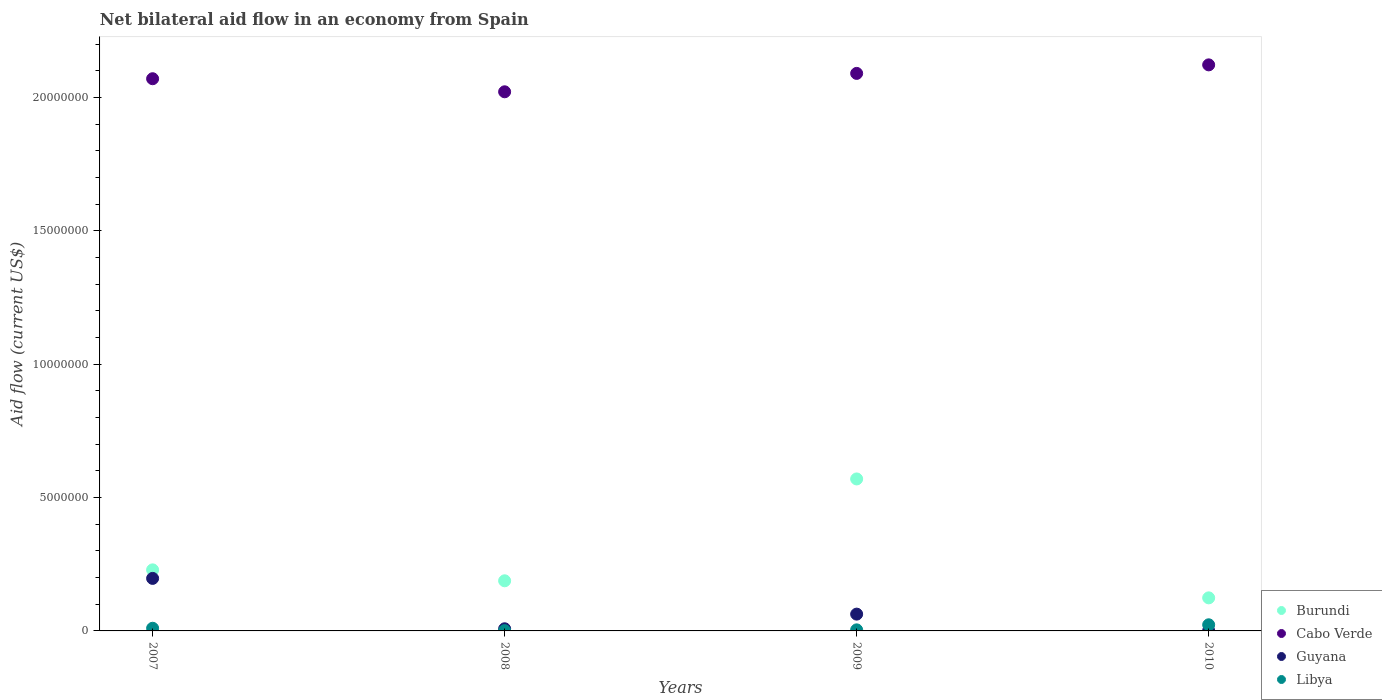What is the net bilateral aid flow in Burundi in 2009?
Ensure brevity in your answer.  5.70e+06. Across all years, what is the maximum net bilateral aid flow in Guyana?
Your answer should be compact. 1.97e+06. Across all years, what is the minimum net bilateral aid flow in Burundi?
Make the answer very short. 1.24e+06. In which year was the net bilateral aid flow in Libya minimum?
Keep it short and to the point. 2008. What is the total net bilateral aid flow in Burundi in the graph?
Provide a short and direct response. 1.11e+07. What is the difference between the net bilateral aid flow in Cabo Verde in 2007 and that in 2010?
Ensure brevity in your answer.  -5.20e+05. What is the difference between the net bilateral aid flow in Burundi in 2010 and the net bilateral aid flow in Libya in 2008?
Make the answer very short. 1.23e+06. What is the average net bilateral aid flow in Burundi per year?
Your answer should be compact. 2.78e+06. In the year 2007, what is the difference between the net bilateral aid flow in Guyana and net bilateral aid flow in Libya?
Give a very brief answer. 1.87e+06. Is the net bilateral aid flow in Libya in 2008 less than that in 2009?
Your response must be concise. Yes. What is the difference between the highest and the lowest net bilateral aid flow in Burundi?
Keep it short and to the point. 4.46e+06. Is the sum of the net bilateral aid flow in Libya in 2008 and 2010 greater than the maximum net bilateral aid flow in Cabo Verde across all years?
Offer a terse response. No. Is it the case that in every year, the sum of the net bilateral aid flow in Burundi and net bilateral aid flow in Guyana  is greater than the sum of net bilateral aid flow in Cabo Verde and net bilateral aid flow in Libya?
Keep it short and to the point. Yes. Is it the case that in every year, the sum of the net bilateral aid flow in Libya and net bilateral aid flow in Burundi  is greater than the net bilateral aid flow in Cabo Verde?
Give a very brief answer. No. Does the net bilateral aid flow in Guyana monotonically increase over the years?
Give a very brief answer. No. Are the values on the major ticks of Y-axis written in scientific E-notation?
Offer a very short reply. No. Does the graph contain grids?
Your response must be concise. No. Where does the legend appear in the graph?
Provide a short and direct response. Bottom right. How many legend labels are there?
Your answer should be very brief. 4. How are the legend labels stacked?
Your response must be concise. Vertical. What is the title of the graph?
Offer a terse response. Net bilateral aid flow in an economy from Spain. Does "Czech Republic" appear as one of the legend labels in the graph?
Ensure brevity in your answer.  No. What is the label or title of the Y-axis?
Your answer should be compact. Aid flow (current US$). What is the Aid flow (current US$) of Burundi in 2007?
Ensure brevity in your answer.  2.29e+06. What is the Aid flow (current US$) of Cabo Verde in 2007?
Offer a terse response. 2.07e+07. What is the Aid flow (current US$) in Guyana in 2007?
Your answer should be compact. 1.97e+06. What is the Aid flow (current US$) of Burundi in 2008?
Make the answer very short. 1.88e+06. What is the Aid flow (current US$) in Cabo Verde in 2008?
Make the answer very short. 2.02e+07. What is the Aid flow (current US$) of Guyana in 2008?
Give a very brief answer. 8.00e+04. What is the Aid flow (current US$) of Libya in 2008?
Provide a short and direct response. 10000. What is the Aid flow (current US$) in Burundi in 2009?
Your answer should be very brief. 5.70e+06. What is the Aid flow (current US$) of Cabo Verde in 2009?
Your answer should be very brief. 2.09e+07. What is the Aid flow (current US$) in Guyana in 2009?
Your answer should be compact. 6.30e+05. What is the Aid flow (current US$) of Libya in 2009?
Offer a very short reply. 4.00e+04. What is the Aid flow (current US$) in Burundi in 2010?
Your response must be concise. 1.24e+06. What is the Aid flow (current US$) of Cabo Verde in 2010?
Your answer should be very brief. 2.12e+07. What is the Aid flow (current US$) of Guyana in 2010?
Provide a short and direct response. 10000. Across all years, what is the maximum Aid flow (current US$) in Burundi?
Give a very brief answer. 5.70e+06. Across all years, what is the maximum Aid flow (current US$) in Cabo Verde?
Make the answer very short. 2.12e+07. Across all years, what is the maximum Aid flow (current US$) of Guyana?
Keep it short and to the point. 1.97e+06. Across all years, what is the minimum Aid flow (current US$) in Burundi?
Your answer should be compact. 1.24e+06. Across all years, what is the minimum Aid flow (current US$) in Cabo Verde?
Your response must be concise. 2.02e+07. What is the total Aid flow (current US$) in Burundi in the graph?
Make the answer very short. 1.11e+07. What is the total Aid flow (current US$) of Cabo Verde in the graph?
Make the answer very short. 8.31e+07. What is the total Aid flow (current US$) of Guyana in the graph?
Make the answer very short. 2.69e+06. What is the difference between the Aid flow (current US$) of Burundi in 2007 and that in 2008?
Keep it short and to the point. 4.10e+05. What is the difference between the Aid flow (current US$) in Guyana in 2007 and that in 2008?
Give a very brief answer. 1.89e+06. What is the difference between the Aid flow (current US$) of Libya in 2007 and that in 2008?
Make the answer very short. 9.00e+04. What is the difference between the Aid flow (current US$) of Burundi in 2007 and that in 2009?
Offer a very short reply. -3.41e+06. What is the difference between the Aid flow (current US$) of Guyana in 2007 and that in 2009?
Ensure brevity in your answer.  1.34e+06. What is the difference between the Aid flow (current US$) of Burundi in 2007 and that in 2010?
Your answer should be very brief. 1.05e+06. What is the difference between the Aid flow (current US$) in Cabo Verde in 2007 and that in 2010?
Provide a succinct answer. -5.20e+05. What is the difference between the Aid flow (current US$) of Guyana in 2007 and that in 2010?
Ensure brevity in your answer.  1.96e+06. What is the difference between the Aid flow (current US$) in Burundi in 2008 and that in 2009?
Provide a succinct answer. -3.82e+06. What is the difference between the Aid flow (current US$) in Cabo Verde in 2008 and that in 2009?
Your answer should be compact. -6.90e+05. What is the difference between the Aid flow (current US$) of Guyana in 2008 and that in 2009?
Your response must be concise. -5.50e+05. What is the difference between the Aid flow (current US$) of Libya in 2008 and that in 2009?
Give a very brief answer. -3.00e+04. What is the difference between the Aid flow (current US$) in Burundi in 2008 and that in 2010?
Provide a succinct answer. 6.40e+05. What is the difference between the Aid flow (current US$) of Cabo Verde in 2008 and that in 2010?
Your response must be concise. -1.01e+06. What is the difference between the Aid flow (current US$) in Libya in 2008 and that in 2010?
Your response must be concise. -2.20e+05. What is the difference between the Aid flow (current US$) in Burundi in 2009 and that in 2010?
Keep it short and to the point. 4.46e+06. What is the difference between the Aid flow (current US$) in Cabo Verde in 2009 and that in 2010?
Make the answer very short. -3.20e+05. What is the difference between the Aid flow (current US$) of Guyana in 2009 and that in 2010?
Your response must be concise. 6.20e+05. What is the difference between the Aid flow (current US$) of Libya in 2009 and that in 2010?
Provide a succinct answer. -1.90e+05. What is the difference between the Aid flow (current US$) in Burundi in 2007 and the Aid flow (current US$) in Cabo Verde in 2008?
Give a very brief answer. -1.79e+07. What is the difference between the Aid flow (current US$) of Burundi in 2007 and the Aid flow (current US$) of Guyana in 2008?
Your answer should be very brief. 2.21e+06. What is the difference between the Aid flow (current US$) of Burundi in 2007 and the Aid flow (current US$) of Libya in 2008?
Keep it short and to the point. 2.28e+06. What is the difference between the Aid flow (current US$) of Cabo Verde in 2007 and the Aid flow (current US$) of Guyana in 2008?
Offer a very short reply. 2.06e+07. What is the difference between the Aid flow (current US$) in Cabo Verde in 2007 and the Aid flow (current US$) in Libya in 2008?
Provide a short and direct response. 2.07e+07. What is the difference between the Aid flow (current US$) in Guyana in 2007 and the Aid flow (current US$) in Libya in 2008?
Your answer should be very brief. 1.96e+06. What is the difference between the Aid flow (current US$) in Burundi in 2007 and the Aid flow (current US$) in Cabo Verde in 2009?
Your response must be concise. -1.86e+07. What is the difference between the Aid flow (current US$) in Burundi in 2007 and the Aid flow (current US$) in Guyana in 2009?
Provide a short and direct response. 1.66e+06. What is the difference between the Aid flow (current US$) of Burundi in 2007 and the Aid flow (current US$) of Libya in 2009?
Your answer should be very brief. 2.25e+06. What is the difference between the Aid flow (current US$) of Cabo Verde in 2007 and the Aid flow (current US$) of Guyana in 2009?
Offer a terse response. 2.01e+07. What is the difference between the Aid flow (current US$) in Cabo Verde in 2007 and the Aid flow (current US$) in Libya in 2009?
Ensure brevity in your answer.  2.07e+07. What is the difference between the Aid flow (current US$) in Guyana in 2007 and the Aid flow (current US$) in Libya in 2009?
Your response must be concise. 1.93e+06. What is the difference between the Aid flow (current US$) in Burundi in 2007 and the Aid flow (current US$) in Cabo Verde in 2010?
Provide a succinct answer. -1.89e+07. What is the difference between the Aid flow (current US$) of Burundi in 2007 and the Aid flow (current US$) of Guyana in 2010?
Offer a terse response. 2.28e+06. What is the difference between the Aid flow (current US$) of Burundi in 2007 and the Aid flow (current US$) of Libya in 2010?
Provide a short and direct response. 2.06e+06. What is the difference between the Aid flow (current US$) in Cabo Verde in 2007 and the Aid flow (current US$) in Guyana in 2010?
Provide a short and direct response. 2.07e+07. What is the difference between the Aid flow (current US$) of Cabo Verde in 2007 and the Aid flow (current US$) of Libya in 2010?
Offer a terse response. 2.05e+07. What is the difference between the Aid flow (current US$) of Guyana in 2007 and the Aid flow (current US$) of Libya in 2010?
Your answer should be compact. 1.74e+06. What is the difference between the Aid flow (current US$) of Burundi in 2008 and the Aid flow (current US$) of Cabo Verde in 2009?
Keep it short and to the point. -1.90e+07. What is the difference between the Aid flow (current US$) of Burundi in 2008 and the Aid flow (current US$) of Guyana in 2009?
Provide a short and direct response. 1.25e+06. What is the difference between the Aid flow (current US$) in Burundi in 2008 and the Aid flow (current US$) in Libya in 2009?
Your answer should be very brief. 1.84e+06. What is the difference between the Aid flow (current US$) in Cabo Verde in 2008 and the Aid flow (current US$) in Guyana in 2009?
Your answer should be compact. 1.96e+07. What is the difference between the Aid flow (current US$) in Cabo Verde in 2008 and the Aid flow (current US$) in Libya in 2009?
Offer a very short reply. 2.02e+07. What is the difference between the Aid flow (current US$) of Burundi in 2008 and the Aid flow (current US$) of Cabo Verde in 2010?
Give a very brief answer. -1.94e+07. What is the difference between the Aid flow (current US$) in Burundi in 2008 and the Aid flow (current US$) in Guyana in 2010?
Provide a succinct answer. 1.87e+06. What is the difference between the Aid flow (current US$) of Burundi in 2008 and the Aid flow (current US$) of Libya in 2010?
Your response must be concise. 1.65e+06. What is the difference between the Aid flow (current US$) of Cabo Verde in 2008 and the Aid flow (current US$) of Guyana in 2010?
Provide a succinct answer. 2.02e+07. What is the difference between the Aid flow (current US$) of Cabo Verde in 2008 and the Aid flow (current US$) of Libya in 2010?
Your answer should be very brief. 2.00e+07. What is the difference between the Aid flow (current US$) in Burundi in 2009 and the Aid flow (current US$) in Cabo Verde in 2010?
Your response must be concise. -1.55e+07. What is the difference between the Aid flow (current US$) in Burundi in 2009 and the Aid flow (current US$) in Guyana in 2010?
Offer a terse response. 5.69e+06. What is the difference between the Aid flow (current US$) of Burundi in 2009 and the Aid flow (current US$) of Libya in 2010?
Provide a short and direct response. 5.47e+06. What is the difference between the Aid flow (current US$) in Cabo Verde in 2009 and the Aid flow (current US$) in Guyana in 2010?
Your answer should be compact. 2.09e+07. What is the difference between the Aid flow (current US$) in Cabo Verde in 2009 and the Aid flow (current US$) in Libya in 2010?
Your answer should be compact. 2.07e+07. What is the average Aid flow (current US$) of Burundi per year?
Your answer should be very brief. 2.78e+06. What is the average Aid flow (current US$) of Cabo Verde per year?
Offer a very short reply. 2.08e+07. What is the average Aid flow (current US$) in Guyana per year?
Your response must be concise. 6.72e+05. What is the average Aid flow (current US$) of Libya per year?
Make the answer very short. 9.50e+04. In the year 2007, what is the difference between the Aid flow (current US$) of Burundi and Aid flow (current US$) of Cabo Verde?
Your response must be concise. -1.84e+07. In the year 2007, what is the difference between the Aid flow (current US$) in Burundi and Aid flow (current US$) in Libya?
Provide a succinct answer. 2.19e+06. In the year 2007, what is the difference between the Aid flow (current US$) of Cabo Verde and Aid flow (current US$) of Guyana?
Offer a very short reply. 1.87e+07. In the year 2007, what is the difference between the Aid flow (current US$) in Cabo Verde and Aid flow (current US$) in Libya?
Provide a succinct answer. 2.06e+07. In the year 2007, what is the difference between the Aid flow (current US$) of Guyana and Aid flow (current US$) of Libya?
Offer a very short reply. 1.87e+06. In the year 2008, what is the difference between the Aid flow (current US$) of Burundi and Aid flow (current US$) of Cabo Verde?
Your response must be concise. -1.83e+07. In the year 2008, what is the difference between the Aid flow (current US$) of Burundi and Aid flow (current US$) of Guyana?
Give a very brief answer. 1.80e+06. In the year 2008, what is the difference between the Aid flow (current US$) of Burundi and Aid flow (current US$) of Libya?
Your response must be concise. 1.87e+06. In the year 2008, what is the difference between the Aid flow (current US$) in Cabo Verde and Aid flow (current US$) in Guyana?
Ensure brevity in your answer.  2.01e+07. In the year 2008, what is the difference between the Aid flow (current US$) of Cabo Verde and Aid flow (current US$) of Libya?
Make the answer very short. 2.02e+07. In the year 2008, what is the difference between the Aid flow (current US$) in Guyana and Aid flow (current US$) in Libya?
Make the answer very short. 7.00e+04. In the year 2009, what is the difference between the Aid flow (current US$) in Burundi and Aid flow (current US$) in Cabo Verde?
Offer a terse response. -1.52e+07. In the year 2009, what is the difference between the Aid flow (current US$) in Burundi and Aid flow (current US$) in Guyana?
Offer a terse response. 5.07e+06. In the year 2009, what is the difference between the Aid flow (current US$) in Burundi and Aid flow (current US$) in Libya?
Provide a short and direct response. 5.66e+06. In the year 2009, what is the difference between the Aid flow (current US$) of Cabo Verde and Aid flow (current US$) of Guyana?
Your answer should be compact. 2.03e+07. In the year 2009, what is the difference between the Aid flow (current US$) in Cabo Verde and Aid flow (current US$) in Libya?
Offer a very short reply. 2.09e+07. In the year 2009, what is the difference between the Aid flow (current US$) in Guyana and Aid flow (current US$) in Libya?
Keep it short and to the point. 5.90e+05. In the year 2010, what is the difference between the Aid flow (current US$) of Burundi and Aid flow (current US$) of Cabo Verde?
Your answer should be very brief. -2.00e+07. In the year 2010, what is the difference between the Aid flow (current US$) in Burundi and Aid flow (current US$) in Guyana?
Provide a short and direct response. 1.23e+06. In the year 2010, what is the difference between the Aid flow (current US$) in Burundi and Aid flow (current US$) in Libya?
Provide a succinct answer. 1.01e+06. In the year 2010, what is the difference between the Aid flow (current US$) of Cabo Verde and Aid flow (current US$) of Guyana?
Your answer should be very brief. 2.12e+07. In the year 2010, what is the difference between the Aid flow (current US$) of Cabo Verde and Aid flow (current US$) of Libya?
Ensure brevity in your answer.  2.10e+07. In the year 2010, what is the difference between the Aid flow (current US$) in Guyana and Aid flow (current US$) in Libya?
Provide a succinct answer. -2.20e+05. What is the ratio of the Aid flow (current US$) in Burundi in 2007 to that in 2008?
Offer a terse response. 1.22. What is the ratio of the Aid flow (current US$) in Cabo Verde in 2007 to that in 2008?
Offer a terse response. 1.02. What is the ratio of the Aid flow (current US$) in Guyana in 2007 to that in 2008?
Your response must be concise. 24.62. What is the ratio of the Aid flow (current US$) of Libya in 2007 to that in 2008?
Your response must be concise. 10. What is the ratio of the Aid flow (current US$) in Burundi in 2007 to that in 2009?
Your answer should be compact. 0.4. What is the ratio of the Aid flow (current US$) of Guyana in 2007 to that in 2009?
Offer a very short reply. 3.13. What is the ratio of the Aid flow (current US$) of Burundi in 2007 to that in 2010?
Provide a short and direct response. 1.85. What is the ratio of the Aid flow (current US$) of Cabo Verde in 2007 to that in 2010?
Your response must be concise. 0.98. What is the ratio of the Aid flow (current US$) of Guyana in 2007 to that in 2010?
Your answer should be very brief. 197. What is the ratio of the Aid flow (current US$) in Libya in 2007 to that in 2010?
Keep it short and to the point. 0.43. What is the ratio of the Aid flow (current US$) in Burundi in 2008 to that in 2009?
Ensure brevity in your answer.  0.33. What is the ratio of the Aid flow (current US$) in Guyana in 2008 to that in 2009?
Your response must be concise. 0.13. What is the ratio of the Aid flow (current US$) in Burundi in 2008 to that in 2010?
Provide a short and direct response. 1.52. What is the ratio of the Aid flow (current US$) in Cabo Verde in 2008 to that in 2010?
Offer a terse response. 0.95. What is the ratio of the Aid flow (current US$) of Libya in 2008 to that in 2010?
Offer a very short reply. 0.04. What is the ratio of the Aid flow (current US$) in Burundi in 2009 to that in 2010?
Keep it short and to the point. 4.6. What is the ratio of the Aid flow (current US$) of Cabo Verde in 2009 to that in 2010?
Ensure brevity in your answer.  0.98. What is the ratio of the Aid flow (current US$) of Libya in 2009 to that in 2010?
Give a very brief answer. 0.17. What is the difference between the highest and the second highest Aid flow (current US$) of Burundi?
Ensure brevity in your answer.  3.41e+06. What is the difference between the highest and the second highest Aid flow (current US$) in Cabo Verde?
Your answer should be very brief. 3.20e+05. What is the difference between the highest and the second highest Aid flow (current US$) in Guyana?
Your answer should be very brief. 1.34e+06. What is the difference between the highest and the second highest Aid flow (current US$) of Libya?
Your answer should be compact. 1.30e+05. What is the difference between the highest and the lowest Aid flow (current US$) of Burundi?
Offer a very short reply. 4.46e+06. What is the difference between the highest and the lowest Aid flow (current US$) of Cabo Verde?
Provide a short and direct response. 1.01e+06. What is the difference between the highest and the lowest Aid flow (current US$) in Guyana?
Ensure brevity in your answer.  1.96e+06. What is the difference between the highest and the lowest Aid flow (current US$) in Libya?
Give a very brief answer. 2.20e+05. 